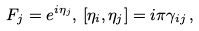<formula> <loc_0><loc_0><loc_500><loc_500>F _ { j } = e ^ { i \eta _ { j } } , \, [ \eta _ { i } , \eta _ { j } ] = i \pi \gamma _ { i j } \, ,</formula> 